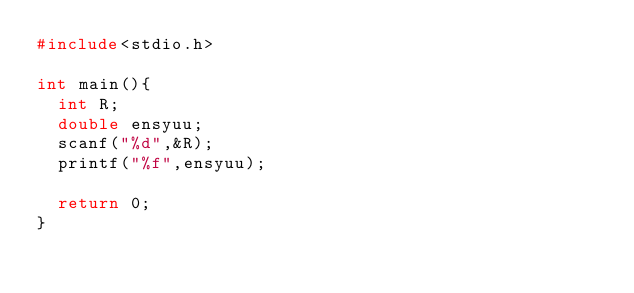<code> <loc_0><loc_0><loc_500><loc_500><_C_>#include<stdio.h>

int main(){
  int R;
  double ensyuu;
  scanf("%d",&R);
  printf("%f",ensyuu);
  
  return 0;
}</code> 